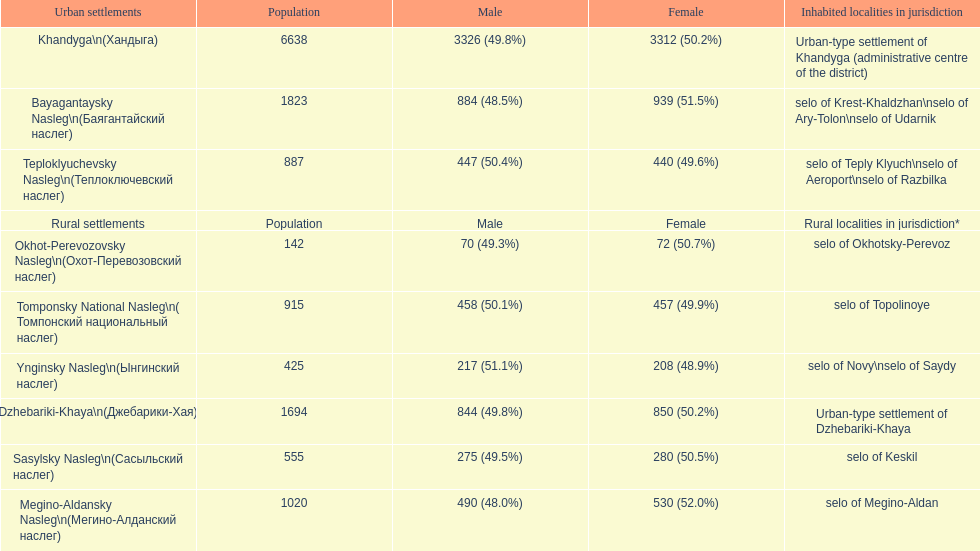Help me parse the entirety of this table. {'header': ['Urban settlements', 'Population', 'Male', 'Female', 'Inhabited localities in jurisdiction'], 'rows': [['Khandyga\\n(Хандыга)', '6638', '3326 (49.8%)', '3312 (50.2%)', 'Urban-type settlement of Khandyga (administrative centre of the district)'], ['Bayagantaysky Nasleg\\n(Баягантайский наслег)', '1823', '884 (48.5%)', '939 (51.5%)', 'selo of Krest-Khaldzhan\\nselo of Ary-Tolon\\nselo of Udarnik'], ['Teploklyuchevsky Nasleg\\n(Теплоключевский наслег)', '887', '447 (50.4%)', '440 (49.6%)', 'selo of Teply Klyuch\\nselo of Aeroport\\nselo of Razbilka'], ['Rural settlements', 'Population', 'Male', 'Female', 'Rural localities in jurisdiction*'], ['Okhot-Perevozovsky Nasleg\\n(Охот-Перевозовский наслег)', '142', '70 (49.3%)', '72 (50.7%)', 'selo of Okhotsky-Perevoz'], ['Tomponsky National Nasleg\\n( Томпонский национальный наслег)', '915', '458 (50.1%)', '457 (49.9%)', 'selo of Topolinoye'], ['Ynginsky Nasleg\\n(Ынгинский наслег)', '425', '217 (51.1%)', '208 (48.9%)', 'selo of Novy\\nselo of Saydy'], ['Dzhebariki-Khaya\\n(Джебарики-Хая)', '1694', '844 (49.8%)', '850 (50.2%)', 'Urban-type settlement of Dzhebariki-Khaya'], ['Sasylsky Nasleg\\n(Сасыльский наслег)', '555', '275 (49.5%)', '280 (50.5%)', 'selo of Keskil'], ['Megino-Aldansky Nasleg\\n(Мегино-Алданский наслег)', '1020', '490 (48.0%)', '530 (52.0%)', 'selo of Megino-Aldan']]} Which rural settlement has the most males in their population? Bayagantaysky Nasleg (Áàÿãàíòàéñêèé íàñëåã). 